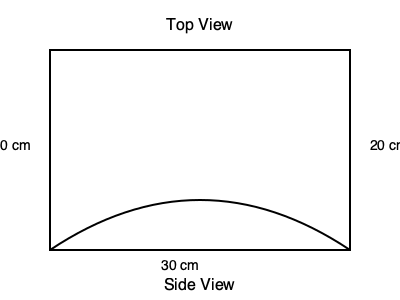As a retired grocery store owner, you've been asked to estimate the volume of a new, irregularly shaped produce container. The container has a rectangular base measuring 30 cm by 20 cm, but its height varies. The side view shows that the height curves from 10 cm at the edges to a maximum height in the center. If we assume the curve is a perfect parabola, what is the volume of this container in cubic centimeters (cm³)? To calculate the volume of this irregularly shaped container, we'll follow these steps:

1. Identify the shape: The container has a rectangular base with a parabolic cross-section.

2. Calculate the area of the base:
   $A_{base} = 30 \text{ cm} \times 20 \text{ cm} = 600 \text{ cm}^2$

3. Determine the average height:
   For a parabolic cross-section, the average height is 2/3 of the maximum height.
   Maximum height = 10 cm
   $h_{avg} = \frac{2}{3} \times 10 \text{ cm} = \frac{20}{3} \text{ cm}$

4. Calculate the volume using the average height method:
   $V = A_{base} \times h_{avg}$
   $V = 600 \text{ cm}^2 \times \frac{20}{3} \text{ cm}$
   $V = 4000 \text{ cm}^3$

Therefore, the volume of the container is 4000 cm³.
Answer: 4000 cm³ 